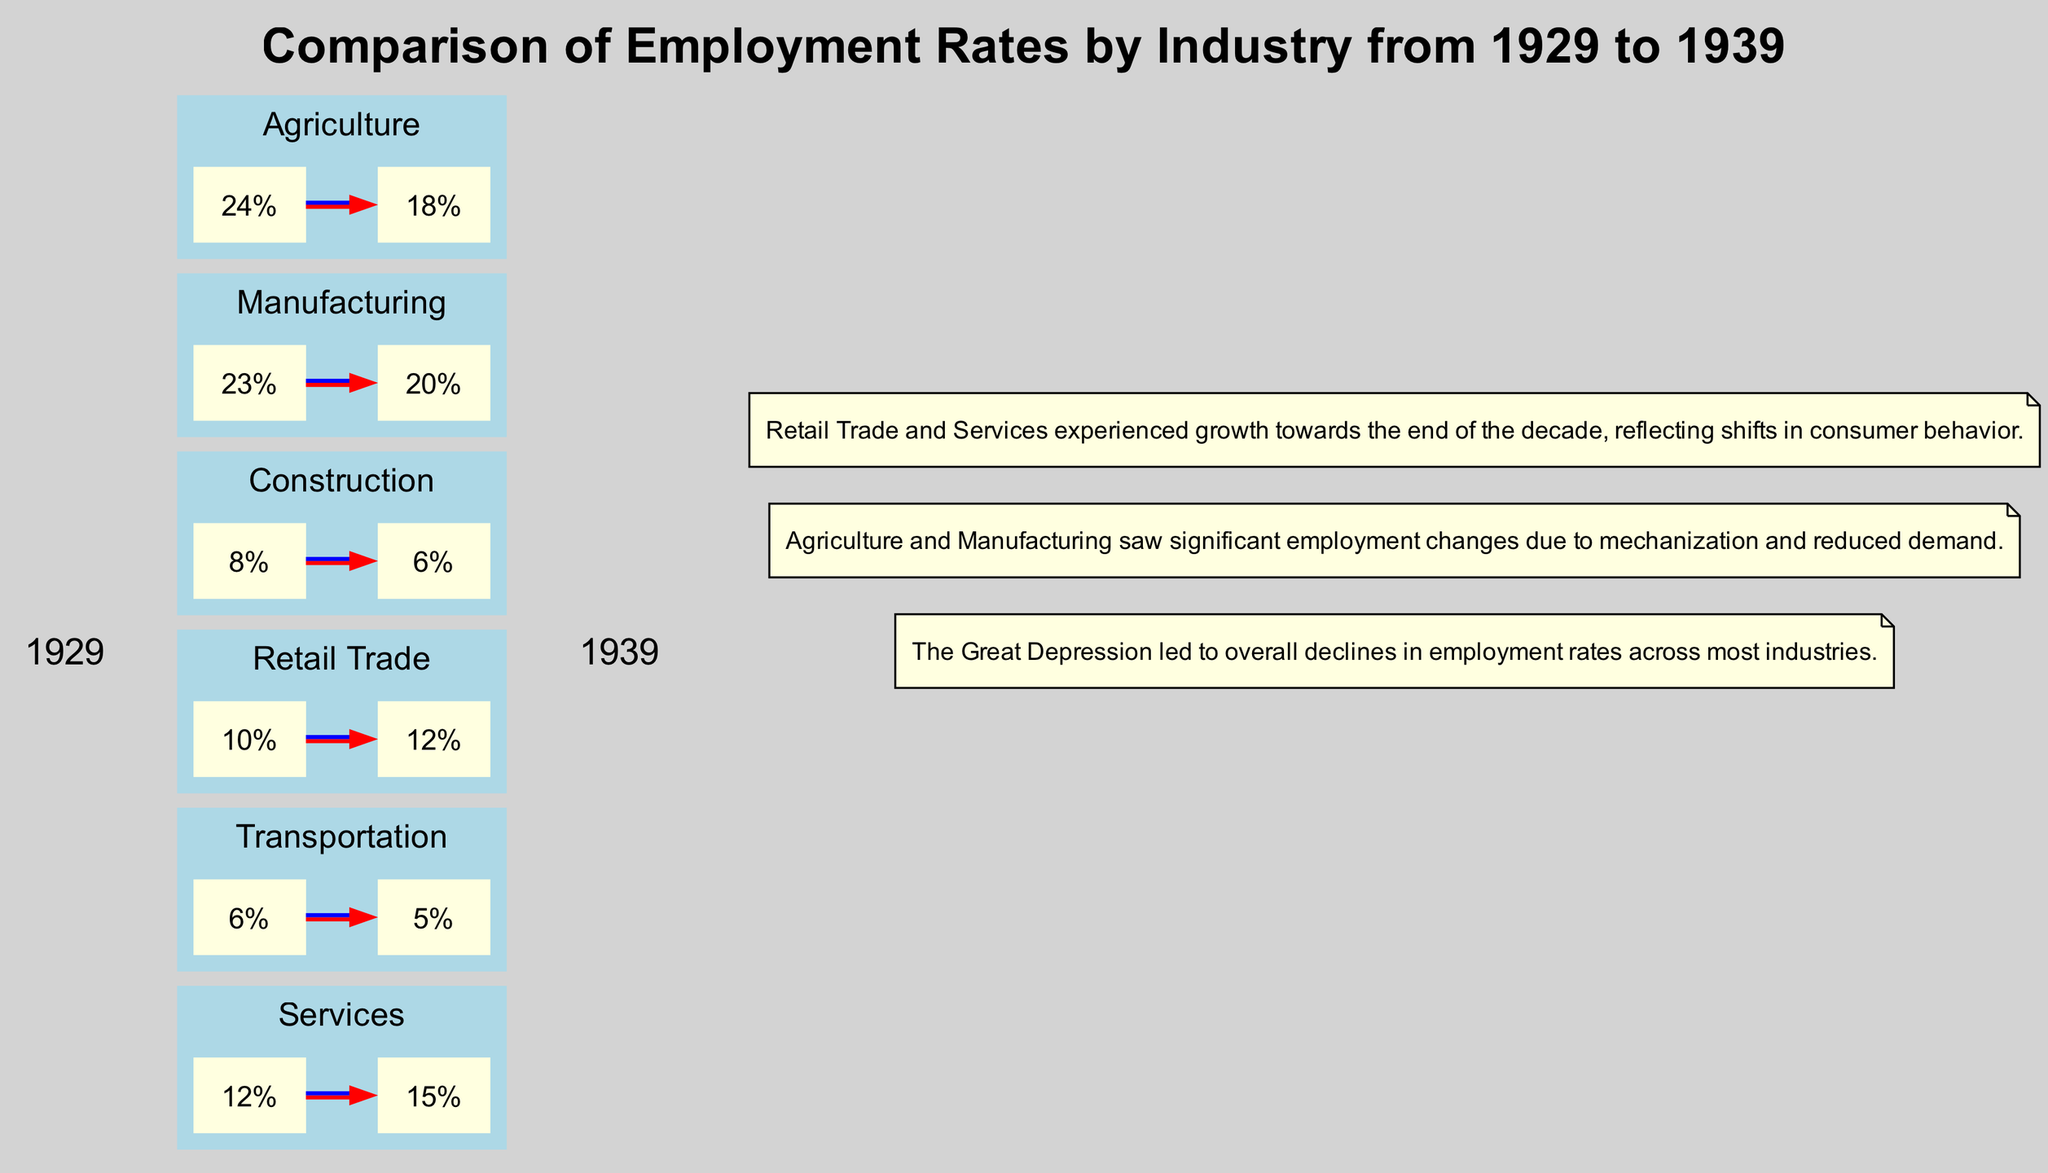What was the employment rate in Agriculture in 1929? The diagram indicates the employment rate for Agriculture in 1929 as 24%, shown in the relevant node labeled "24%".
Answer: 24% What was the employment rate in Services in 1939? According to the diagram, the employment rate for Services in 1939 is represented as 15%, indicated in the node for Services under the 1939 label.
Answer: 15% Which industry had the highest employment rate in 1929? By comparing all the rates in the diagram for 1929, Agriculture and Manufacturing both have the highest rate at 24% and 23%, respectively, but Agriculture has the highest of the two.
Answer: Agriculture Was there an increase or decrease in employment rates for Construction from 1929 to 1939? The edge connecting the rates for Construction from 1929 to 1939 shows that the rate decreased from 8% in 1929 to 6% in 1939, indicating a decline.
Answer: Decrease How many industries experienced a decline in employment rates from 1929 to 1939? By analyzing the employment rates shown in the diagram, Agriculture, Manufacturing, and Construction all show declines while Retail Trade, Transportation, and Services show increases. Thus, three industries had declines.
Answer: Three What does the edge color represent between employment rates of the same industry? The red to blue edge color represents the change in employment rates from 1929 to 1939 for the same industry, indicating a visual transition from one rate to another.
Answer: Change in employment rates Which industry had the lowest employment rate in 1939? Looking at the 1939 rates in the diagram, Transportation has the lowest employment rate at 5%, marked prominently in that section.
Answer: Transportation What was the observed trend in Retail Trade employment rates from 1929 to 1939? The diagram depicts an increase in the employment rate for Retail Trade from 10% in 1929 to 12% in 1939, showing a growth trend.
Answer: Increase Which industry saw an increase in employment rates despite the overall declines across most sectors? From the employment rate figures in the diagram, both Retail Trade and Services experienced increases, with Services going from 12% in 1929 to 15% in 1939 being notable.
Answer: Services 